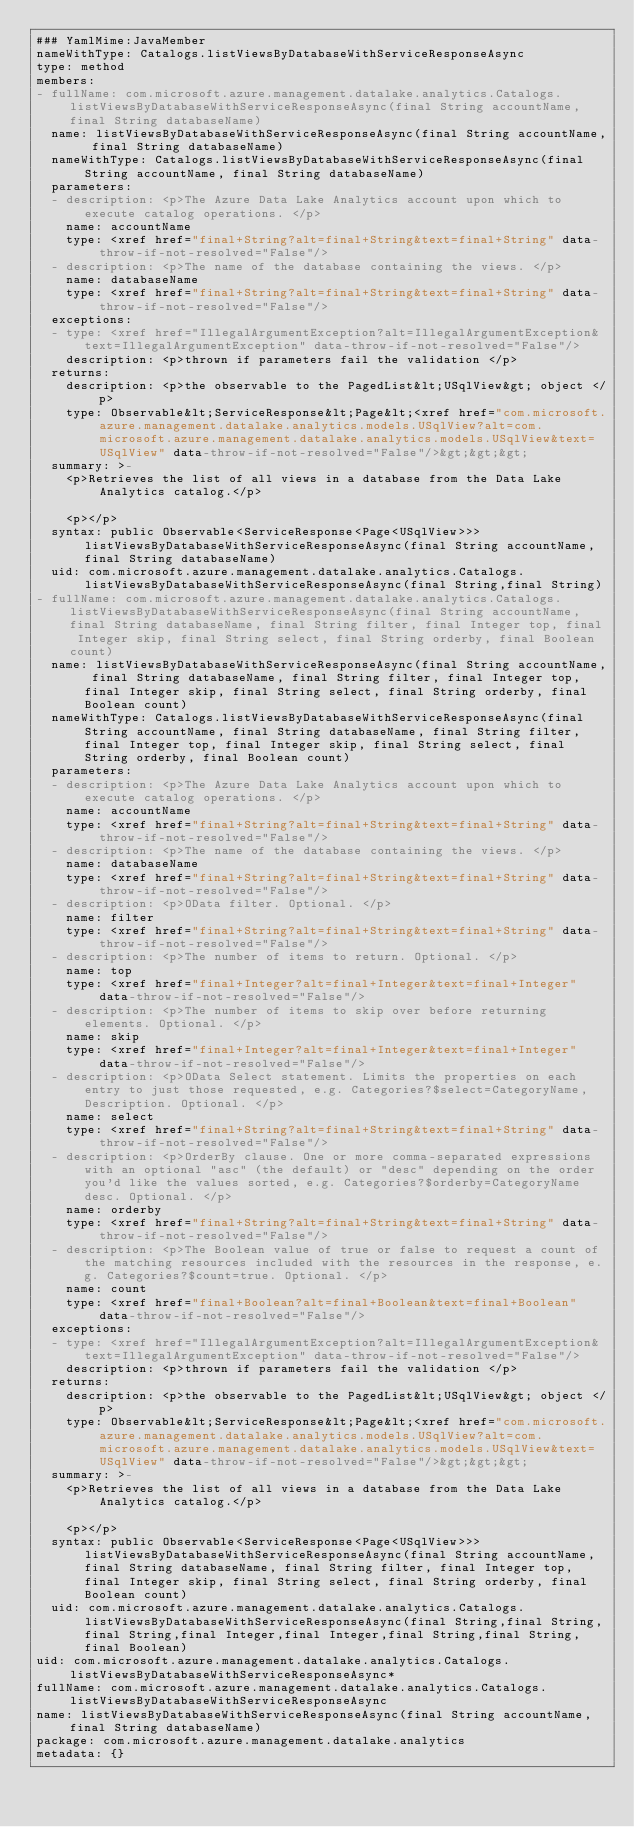Convert code to text. <code><loc_0><loc_0><loc_500><loc_500><_YAML_>### YamlMime:JavaMember
nameWithType: Catalogs.listViewsByDatabaseWithServiceResponseAsync
type: method
members:
- fullName: com.microsoft.azure.management.datalake.analytics.Catalogs.listViewsByDatabaseWithServiceResponseAsync(final String accountName, final String databaseName)
  name: listViewsByDatabaseWithServiceResponseAsync(final String accountName, final String databaseName)
  nameWithType: Catalogs.listViewsByDatabaseWithServiceResponseAsync(final String accountName, final String databaseName)
  parameters:
  - description: <p>The Azure Data Lake Analytics account upon which to execute catalog operations. </p>
    name: accountName
    type: <xref href="final+String?alt=final+String&text=final+String" data-throw-if-not-resolved="False"/>
  - description: <p>The name of the database containing the views. </p>
    name: databaseName
    type: <xref href="final+String?alt=final+String&text=final+String" data-throw-if-not-resolved="False"/>
  exceptions:
  - type: <xref href="IllegalArgumentException?alt=IllegalArgumentException&text=IllegalArgumentException" data-throw-if-not-resolved="False"/>
    description: <p>thrown if parameters fail the validation </p>
  returns:
    description: <p>the observable to the PagedList&lt;USqlView&gt; object </p>
    type: Observable&lt;ServiceResponse&lt;Page&lt;<xref href="com.microsoft.azure.management.datalake.analytics.models.USqlView?alt=com.microsoft.azure.management.datalake.analytics.models.USqlView&text=USqlView" data-throw-if-not-resolved="False"/>&gt;&gt;&gt;
  summary: >-
    <p>Retrieves the list of all views in a database from the Data Lake Analytics catalog.</p>

    <p></p>
  syntax: public Observable<ServiceResponse<Page<USqlView>>> listViewsByDatabaseWithServiceResponseAsync(final String accountName, final String databaseName)
  uid: com.microsoft.azure.management.datalake.analytics.Catalogs.listViewsByDatabaseWithServiceResponseAsync(final String,final String)
- fullName: com.microsoft.azure.management.datalake.analytics.Catalogs.listViewsByDatabaseWithServiceResponseAsync(final String accountName, final String databaseName, final String filter, final Integer top, final Integer skip, final String select, final String orderby, final Boolean count)
  name: listViewsByDatabaseWithServiceResponseAsync(final String accountName, final String databaseName, final String filter, final Integer top, final Integer skip, final String select, final String orderby, final Boolean count)
  nameWithType: Catalogs.listViewsByDatabaseWithServiceResponseAsync(final String accountName, final String databaseName, final String filter, final Integer top, final Integer skip, final String select, final String orderby, final Boolean count)
  parameters:
  - description: <p>The Azure Data Lake Analytics account upon which to execute catalog operations. </p>
    name: accountName
    type: <xref href="final+String?alt=final+String&text=final+String" data-throw-if-not-resolved="False"/>
  - description: <p>The name of the database containing the views. </p>
    name: databaseName
    type: <xref href="final+String?alt=final+String&text=final+String" data-throw-if-not-resolved="False"/>
  - description: <p>OData filter. Optional. </p>
    name: filter
    type: <xref href="final+String?alt=final+String&text=final+String" data-throw-if-not-resolved="False"/>
  - description: <p>The number of items to return. Optional. </p>
    name: top
    type: <xref href="final+Integer?alt=final+Integer&text=final+Integer" data-throw-if-not-resolved="False"/>
  - description: <p>The number of items to skip over before returning elements. Optional. </p>
    name: skip
    type: <xref href="final+Integer?alt=final+Integer&text=final+Integer" data-throw-if-not-resolved="False"/>
  - description: <p>OData Select statement. Limits the properties on each entry to just those requested, e.g. Categories?$select=CategoryName,Description. Optional. </p>
    name: select
    type: <xref href="final+String?alt=final+String&text=final+String" data-throw-if-not-resolved="False"/>
  - description: <p>OrderBy clause. One or more comma-separated expressions with an optional "asc" (the default) or "desc" depending on the order you'd like the values sorted, e.g. Categories?$orderby=CategoryName desc. Optional. </p>
    name: orderby
    type: <xref href="final+String?alt=final+String&text=final+String" data-throw-if-not-resolved="False"/>
  - description: <p>The Boolean value of true or false to request a count of the matching resources included with the resources in the response, e.g. Categories?$count=true. Optional. </p>
    name: count
    type: <xref href="final+Boolean?alt=final+Boolean&text=final+Boolean" data-throw-if-not-resolved="False"/>
  exceptions:
  - type: <xref href="IllegalArgumentException?alt=IllegalArgumentException&text=IllegalArgumentException" data-throw-if-not-resolved="False"/>
    description: <p>thrown if parameters fail the validation </p>
  returns:
    description: <p>the observable to the PagedList&lt;USqlView&gt; object </p>
    type: Observable&lt;ServiceResponse&lt;Page&lt;<xref href="com.microsoft.azure.management.datalake.analytics.models.USqlView?alt=com.microsoft.azure.management.datalake.analytics.models.USqlView&text=USqlView" data-throw-if-not-resolved="False"/>&gt;&gt;&gt;
  summary: >-
    <p>Retrieves the list of all views in a database from the Data Lake Analytics catalog.</p>

    <p></p>
  syntax: public Observable<ServiceResponse<Page<USqlView>>> listViewsByDatabaseWithServiceResponseAsync(final String accountName, final String databaseName, final String filter, final Integer top, final Integer skip, final String select, final String orderby, final Boolean count)
  uid: com.microsoft.azure.management.datalake.analytics.Catalogs.listViewsByDatabaseWithServiceResponseAsync(final String,final String,final String,final Integer,final Integer,final String,final String,final Boolean)
uid: com.microsoft.azure.management.datalake.analytics.Catalogs.listViewsByDatabaseWithServiceResponseAsync*
fullName: com.microsoft.azure.management.datalake.analytics.Catalogs.listViewsByDatabaseWithServiceResponseAsync
name: listViewsByDatabaseWithServiceResponseAsync(final String accountName, final String databaseName)
package: com.microsoft.azure.management.datalake.analytics
metadata: {}
</code> 